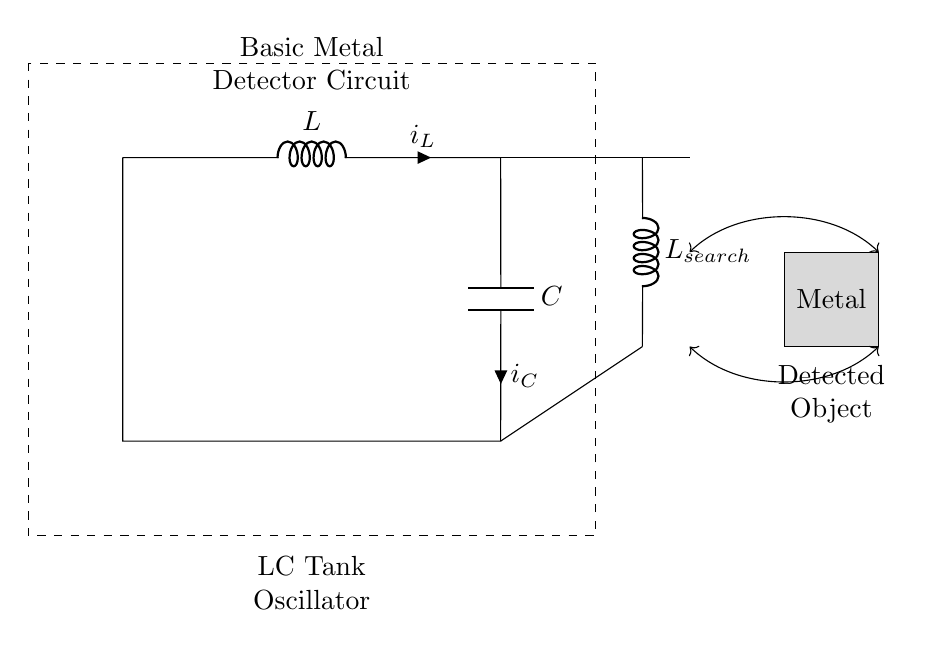What components are in the LC tank circuit? The components are an inductor (L) and a capacitor (C). They are connected in series to form the LC tank circuit, indicated by the labels next to them.
Answer: an inductor and a capacitor What is the purpose of the search coil labeled L_search? The search coil is used to detect metallic objects by inducing changes in the magnetic field in the presence of a metal. It connects to the LC circuit, affecting the resonance frequency.
Answer: to detect metallic objects What is the orientation of the metal object relative to the circuit? The metal object is positioned below the search coil, visually indicated by its location in the diagram.
Answer: below the search coil What type of circuit is displayed in the diagram? The circuit is an LC tank oscillator circuit, characterized by its resonant behavior with the inductor and the capacitor working together.
Answer: LC tank oscillator What will happen to the circuit's oscillation frequency when a metal object is detected? The oscillation frequency will change when a metal object is present, due to the changes in inductance or capacity that affect the resonant frequency.
Answer: frequency will change How many main connections are made in the LC tank circuit? There are three main connections in the LC tank circuit: one between the inductor and capacitor, and two connections to the ground.
Answer: three main connections What is the energy source for the LC tank circuit? The circuit diagram does not show an explicit energy source; however, LC circuits typically require an external source for initial oscillations.
Answer: external source (not shown) 